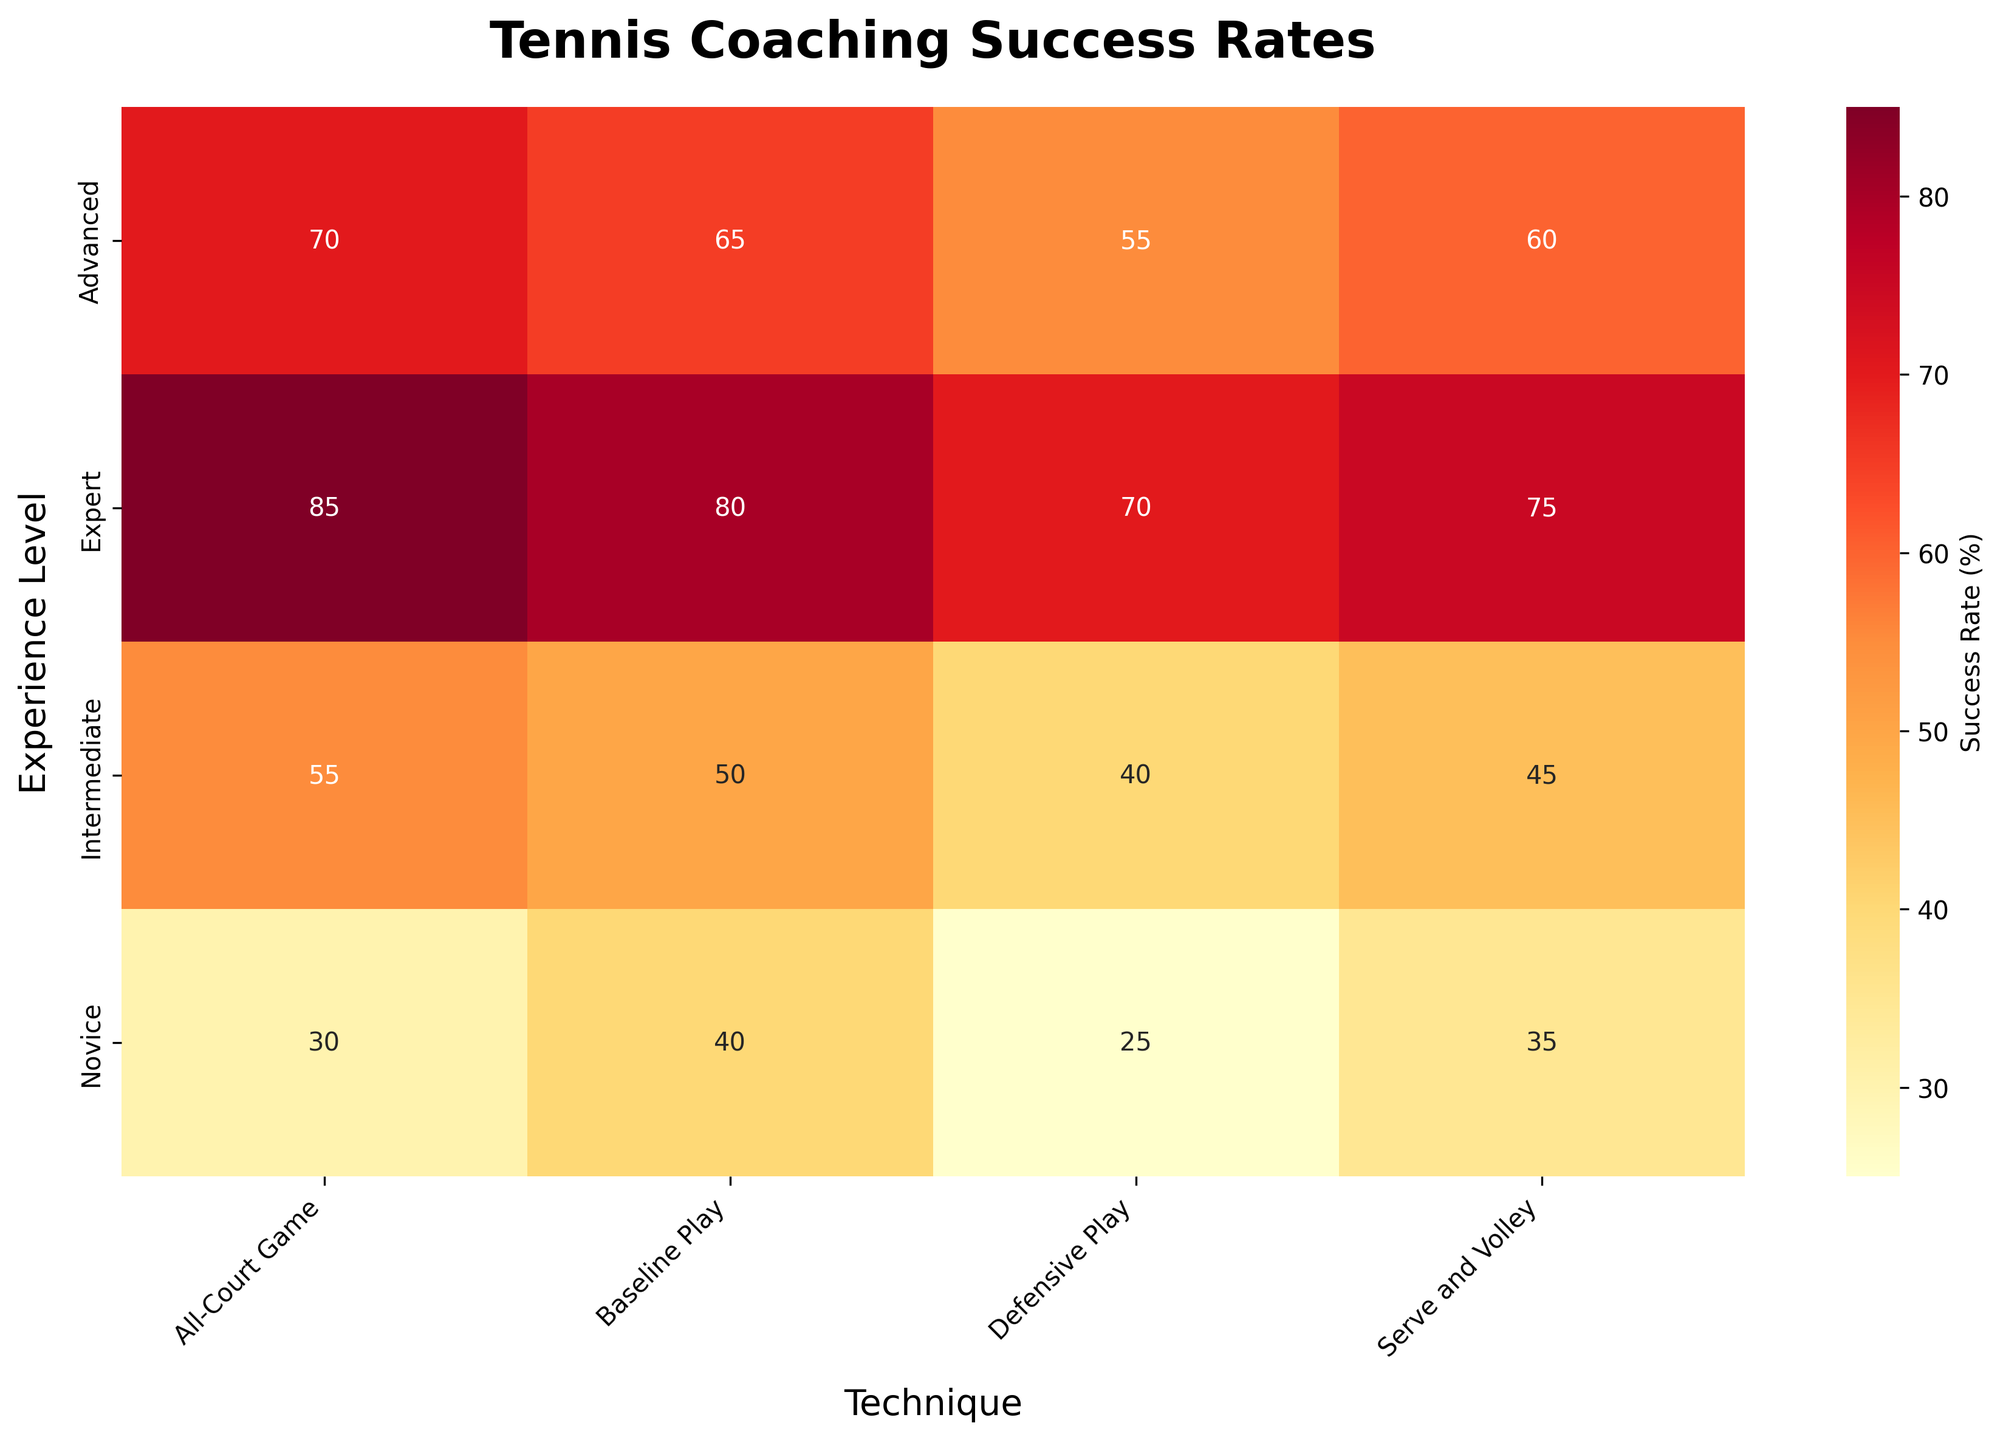What is the title of the heatmap? The title of the heatmap is written at the top of the figure.
Answer: Tennis Coaching Success Rates How does the success rate of Serve and Volley technique change across experience levels? Look at the cells under the Serve and Volley technique across different experience levels and observe the success rates. The rates are 35% for Novice, 45% for Intermediate, 60% for Advanced, and 75% for Expert.
Answer: It increases from 35% to 75% What is the highest success rate depicted in the heatmap? Examine all cells in the heatmap to identify the cell with the highest value. The highest value is in the Expert level using All-Court Game technique, which is 85%.
Answer: 85% Which experience level has the lowest success rate for All-Court Game? Look at the column for All-Court Game and identify the lowest value among the experience levels. The Novice level has the lowest success rate at 30%.
Answer: Novice What is the average success rate for Intermediate across all techniques? Add the success rates for Intermediate and divide by the number of techniques: (45 + 50 + 55 + 40) / 4 = 190 / 4 = 47.5.
Answer: 47.5% Compare the success rates between baseline play and defensive play for Advanced experience level. Which is higher and by how much? Identify the success rates for Baseline Play and Defensive Play under Advanced, which are 65% and 55%, respectively. The difference is 65% - 55% = 10%.
Answer: Baseline Play is higher by 10% How does the success rate of Baseline Play compare between Novice and Expert levels? Observe the Baseline Play success rates for Novice (40%) and Expert (80%). The difference is 80% - 40% = 40%.
Answer: Expert is higher by 40% Which technique shows the least variation in success rate across experience levels? Calculate the range (maximum - minimum) for each technique: Serve and Volley (75-35=40), Baseline Play (80-40=40), All-Court Game (85-30=55), Defensive Play (70-25=45).
Answer: Serve and Volley and Baseline Play Is there any technique in which Novice players have a higher success rate than Intermediate players? Compare each technique's success rate between Novice and Intermediate. Serve and Volley (35 vs 45), Baseline Play (40 vs 50), All-Court Game (30 vs 55), Defensive Play (25 vs 40). No instance shows Novice having a higher rate.
Answer: No Which technique has the highest success rate for Intermediate experience level? Examine the success rates in the Intermediate row. The values are Serve and Volley (45), Baseline Play (50), All-Court Game (55), Defensive Play (40). The highest is All-Court Game with 55%.
Answer: All-Court Game 